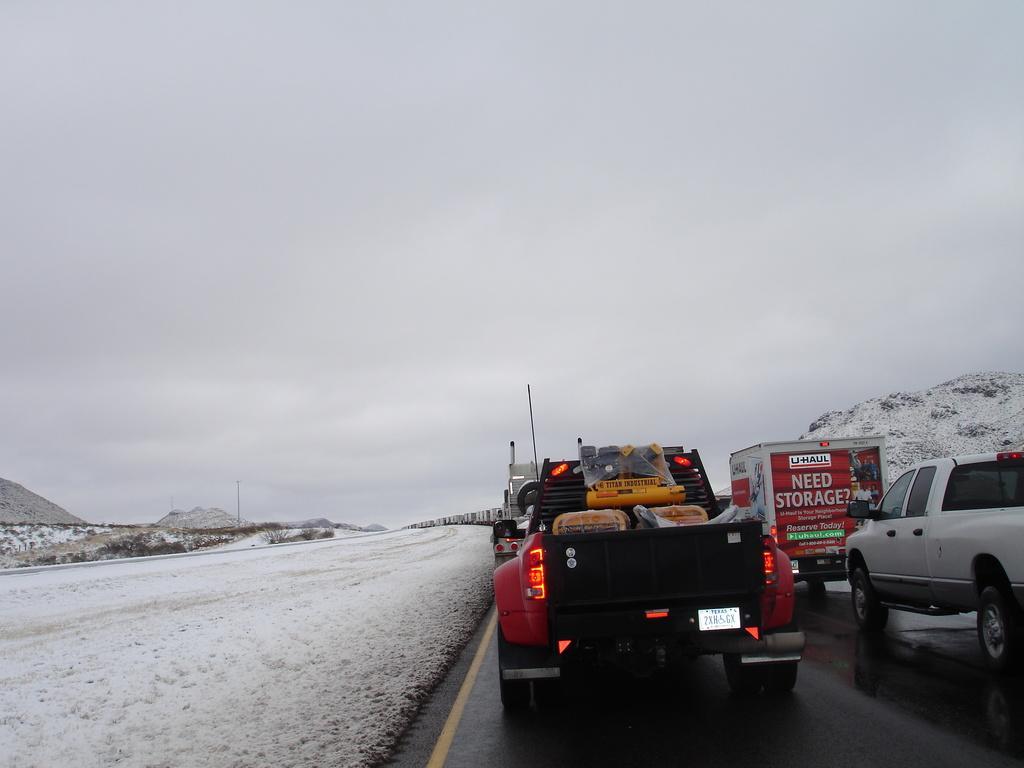Could you give a brief overview of what you see in this image? Towards right there are vehicles moving on the road. On the left it is snow. In the background towards left there are trees and hills. On the left there is a hill. Sky is cloudy. 